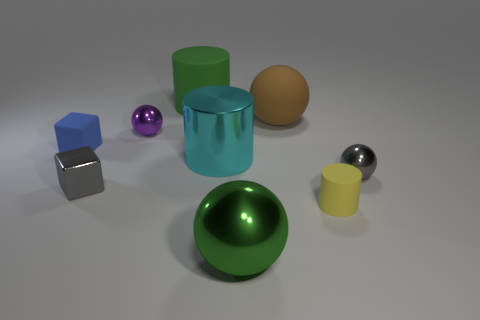Can you tell me about the lighting in the image and how it affects the appearance of the objects? The lighting in the image appears to be soft and diffused, possibly from an overhead source. It creates gentle shadows and highlights, which contribute to the three-dimensional appearance of the objects. The matte surfaces diffuse the light evenly while the reflective surfaces create distinct highlights and mirrored reflections. Does the lighting affect the color perception of these objects? Yes, the lighting has a significant impact on color perception. Soft lighting with diffused shadows can make colors appear more true to their hue without harsh contrasts, whereas direct lighting might create stronger highlights and deepen shadows, altering the perceived saturation and brightness of the colors. 